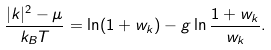<formula> <loc_0><loc_0><loc_500><loc_500>\frac { | k | ^ { 2 } - \mu } { k _ { B } T } = \ln ( 1 + w _ { k } ) - g \ln \frac { 1 + w _ { k } } { w _ { k } } .</formula> 